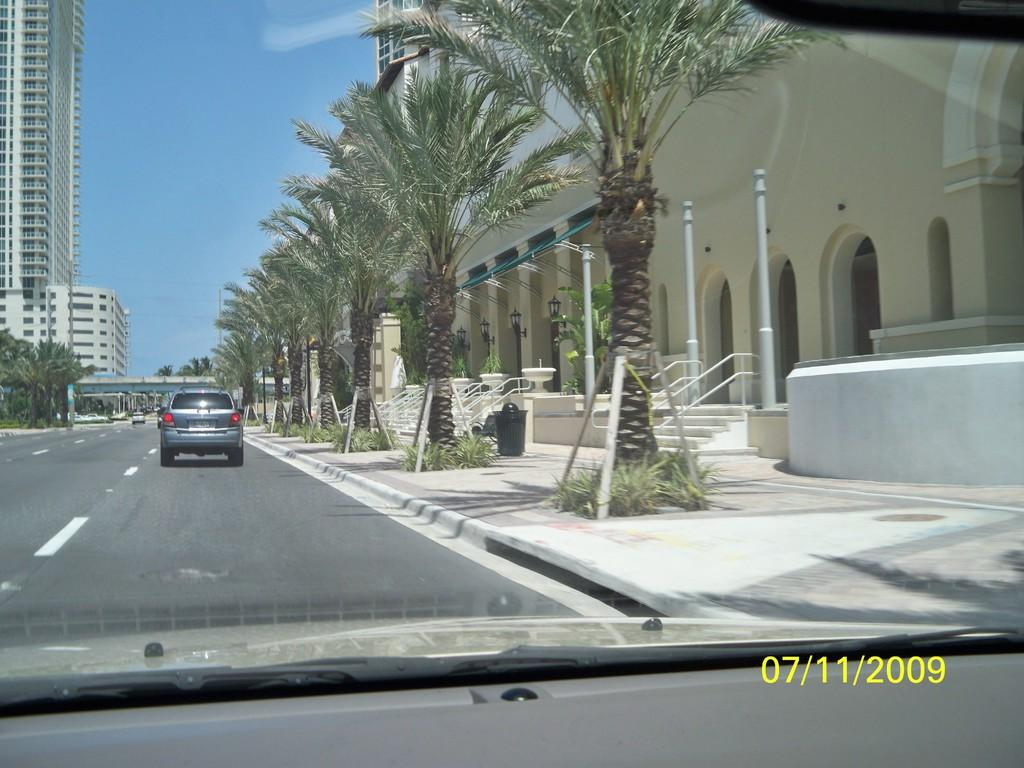What type of vehicles can be seen on the road in the image? There are cars on the road in the image. What other elements can be seen in the image besides the cars? There are trees, buildings, a bridge, poles, a bin, and steps visible in the image. What is visible in the background of the image? The sky is visible in the background of the image. What type of act is being performed by the expansion in the image? There is no act or expansion present in the image. What type of loss is depicted in the image? There is no loss depicted in the image. 